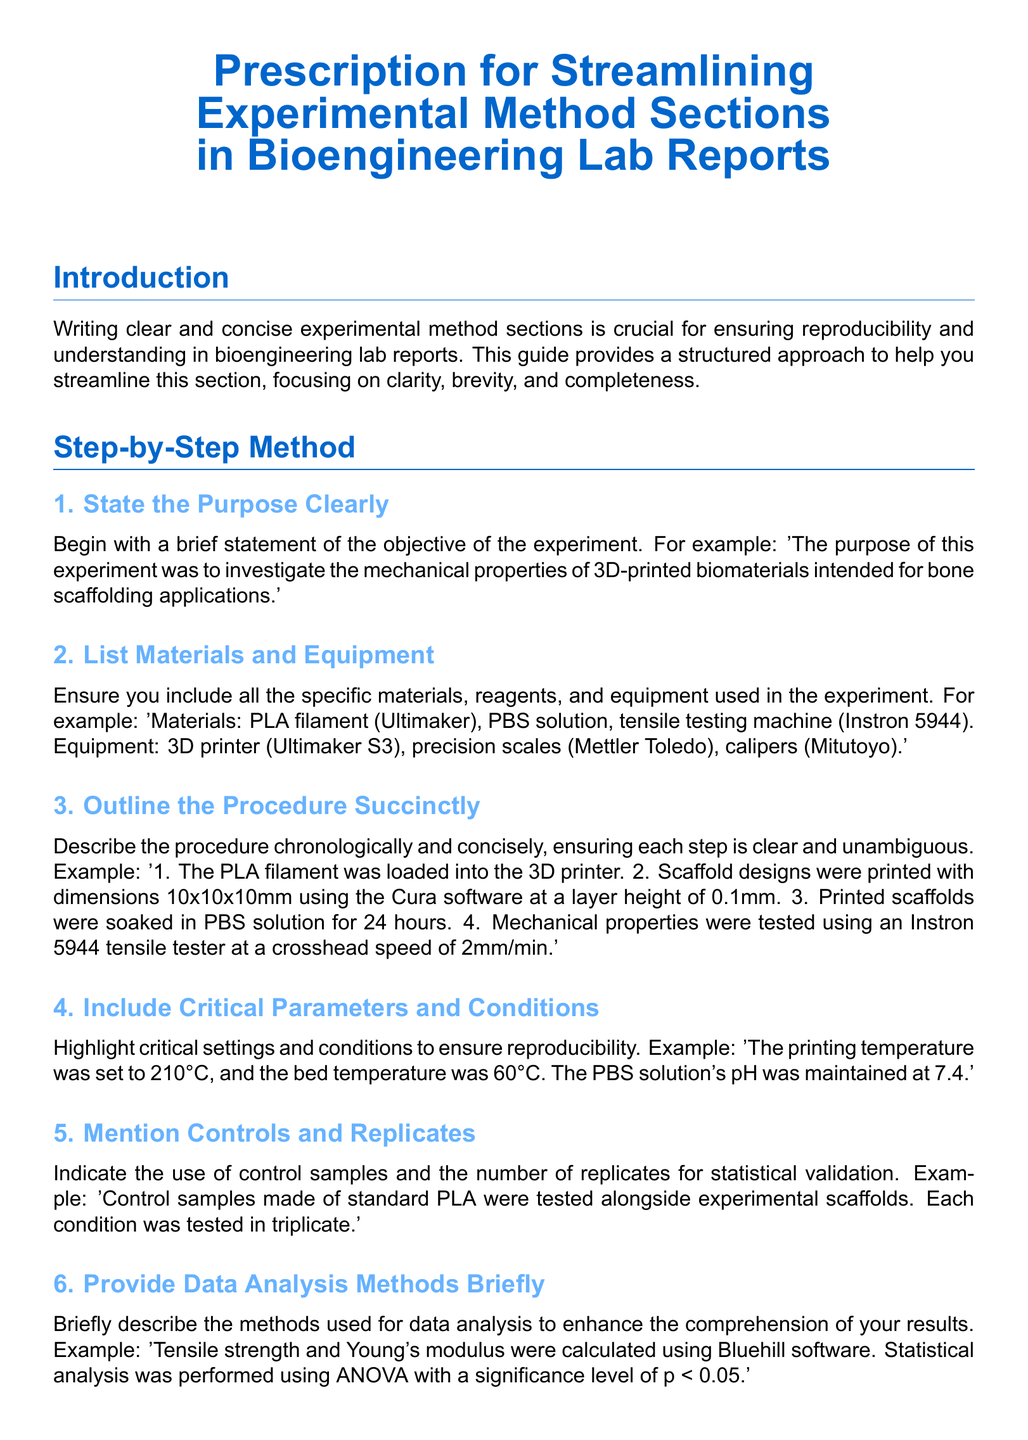What is the main focus of the guide? The introduction states that the guide focuses on writing clear and concise experimental method sections for bioengineering lab reports.
Answer: clarity, brevity, and completeness What is the purpose of the experiment example provided? The example states the objective of the experiment regarding mechanical properties of 3D-printed biomaterials for bone scaffolding.
Answer: investigate the mechanical properties of 3D-printed biomaterials intended for bone scaffolding applications How many materials and equipment are listed in the example? The section provides examples of 3 materials and 3 pieces of equipment, totaling 6 items.
Answer: 6 What is the printing temperature mentioned? The critical parameter states the printing temperature for the experiment.
Answer: 210°C How many replicates were tested for each condition? The document specifies the number of replicates used for statistical validation.
Answer: triplicate What is one common mistake to avoid? The section lists several mistakes, including using ambiguous terms or jargon.
Answer: ambiguous terms Which software was used for data analysis? The example states that Bluehill software was used to calculate tensile strength and Young's modulus.
Answer: Bluehill software What statistical analysis method is mentioned? The section instructs that ANOVA is used for statistical analysis with a significance level.
Answer: ANOVA What is the significance level mentioned for the statistical analysis? The document specifies the significance level required for the statistical analysis of the results.
Answer: p < 0.05 